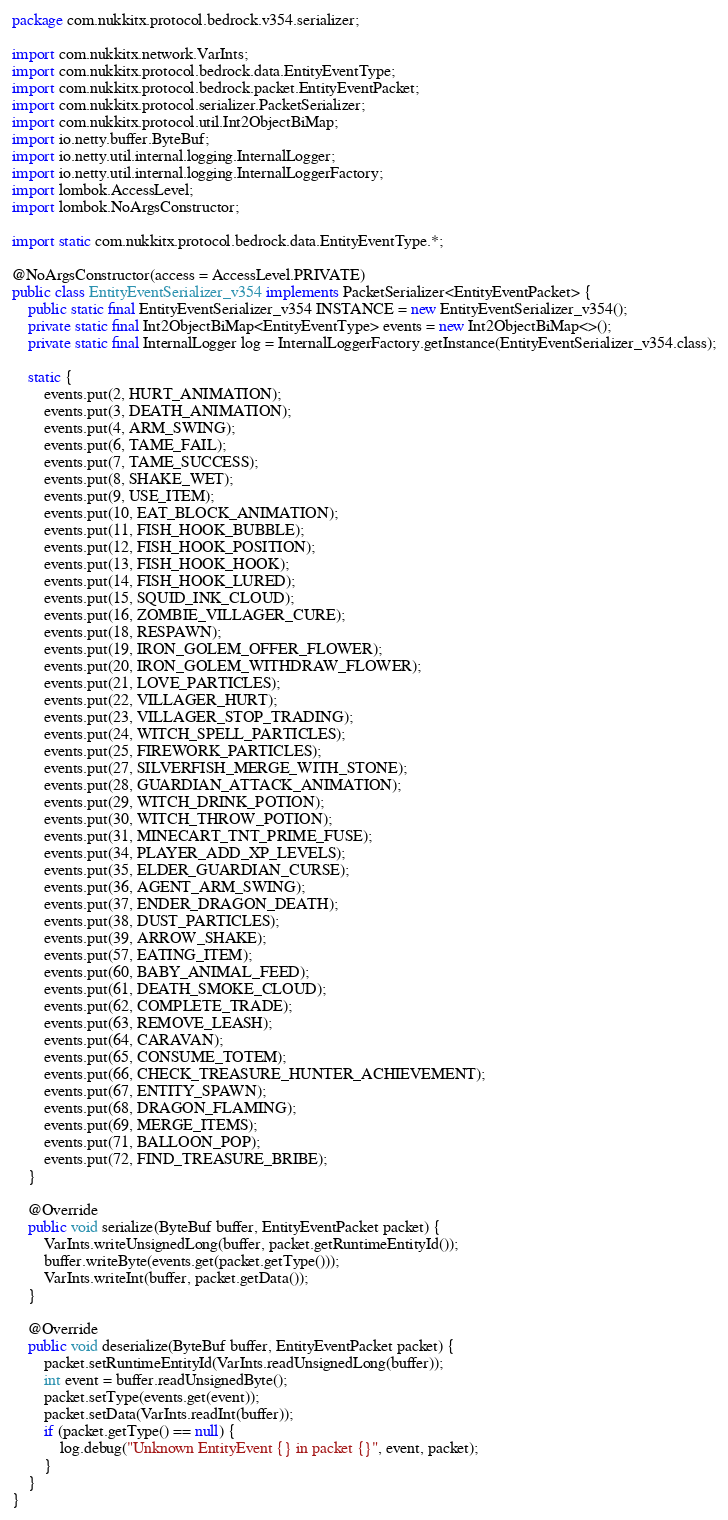Convert code to text. <code><loc_0><loc_0><loc_500><loc_500><_Java_>package com.nukkitx.protocol.bedrock.v354.serializer;

import com.nukkitx.network.VarInts;
import com.nukkitx.protocol.bedrock.data.EntityEventType;
import com.nukkitx.protocol.bedrock.packet.EntityEventPacket;
import com.nukkitx.protocol.serializer.PacketSerializer;
import com.nukkitx.protocol.util.Int2ObjectBiMap;
import io.netty.buffer.ByteBuf;
import io.netty.util.internal.logging.InternalLogger;
import io.netty.util.internal.logging.InternalLoggerFactory;
import lombok.AccessLevel;
import lombok.NoArgsConstructor;

import static com.nukkitx.protocol.bedrock.data.EntityEventType.*;

@NoArgsConstructor(access = AccessLevel.PRIVATE)
public class EntityEventSerializer_v354 implements PacketSerializer<EntityEventPacket> {
    public static final EntityEventSerializer_v354 INSTANCE = new EntityEventSerializer_v354();
    private static final Int2ObjectBiMap<EntityEventType> events = new Int2ObjectBiMap<>();
    private static final InternalLogger log = InternalLoggerFactory.getInstance(EntityEventSerializer_v354.class);

    static {
        events.put(2, HURT_ANIMATION);
        events.put(3, DEATH_ANIMATION);
        events.put(4, ARM_SWING);
        events.put(6, TAME_FAIL);
        events.put(7, TAME_SUCCESS);
        events.put(8, SHAKE_WET);
        events.put(9, USE_ITEM);
        events.put(10, EAT_BLOCK_ANIMATION);
        events.put(11, FISH_HOOK_BUBBLE);
        events.put(12, FISH_HOOK_POSITION);
        events.put(13, FISH_HOOK_HOOK);
        events.put(14, FISH_HOOK_LURED);
        events.put(15, SQUID_INK_CLOUD);
        events.put(16, ZOMBIE_VILLAGER_CURE);
        events.put(18, RESPAWN);
        events.put(19, IRON_GOLEM_OFFER_FLOWER);
        events.put(20, IRON_GOLEM_WITHDRAW_FLOWER);
        events.put(21, LOVE_PARTICLES);
        events.put(22, VILLAGER_HURT);
        events.put(23, VILLAGER_STOP_TRADING);
        events.put(24, WITCH_SPELL_PARTICLES);
        events.put(25, FIREWORK_PARTICLES);
        events.put(27, SILVERFISH_MERGE_WITH_STONE);
        events.put(28, GUARDIAN_ATTACK_ANIMATION);
        events.put(29, WITCH_DRINK_POTION);
        events.put(30, WITCH_THROW_POTION);
        events.put(31, MINECART_TNT_PRIME_FUSE);
        events.put(34, PLAYER_ADD_XP_LEVELS);
        events.put(35, ELDER_GUARDIAN_CURSE);
        events.put(36, AGENT_ARM_SWING);
        events.put(37, ENDER_DRAGON_DEATH);
        events.put(38, DUST_PARTICLES);
        events.put(39, ARROW_SHAKE);
        events.put(57, EATING_ITEM);
        events.put(60, BABY_ANIMAL_FEED);
        events.put(61, DEATH_SMOKE_CLOUD);
        events.put(62, COMPLETE_TRADE);
        events.put(63, REMOVE_LEASH);
        events.put(64, CARAVAN);
        events.put(65, CONSUME_TOTEM);
        events.put(66, CHECK_TREASURE_HUNTER_ACHIEVEMENT);
        events.put(67, ENTITY_SPAWN);
        events.put(68, DRAGON_FLAMING);
        events.put(69, MERGE_ITEMS);
        events.put(71, BALLOON_POP);
        events.put(72, FIND_TREASURE_BRIBE);
    }

    @Override
    public void serialize(ByteBuf buffer, EntityEventPacket packet) {
        VarInts.writeUnsignedLong(buffer, packet.getRuntimeEntityId());
        buffer.writeByte(events.get(packet.getType()));
        VarInts.writeInt(buffer, packet.getData());
    }

    @Override
    public void deserialize(ByteBuf buffer, EntityEventPacket packet) {
        packet.setRuntimeEntityId(VarInts.readUnsignedLong(buffer));
        int event = buffer.readUnsignedByte();
        packet.setType(events.get(event));
        packet.setData(VarInts.readInt(buffer));
        if (packet.getType() == null) {
            log.debug("Unknown EntityEvent {} in packet {}", event, packet);
        }
    }
}
</code> 